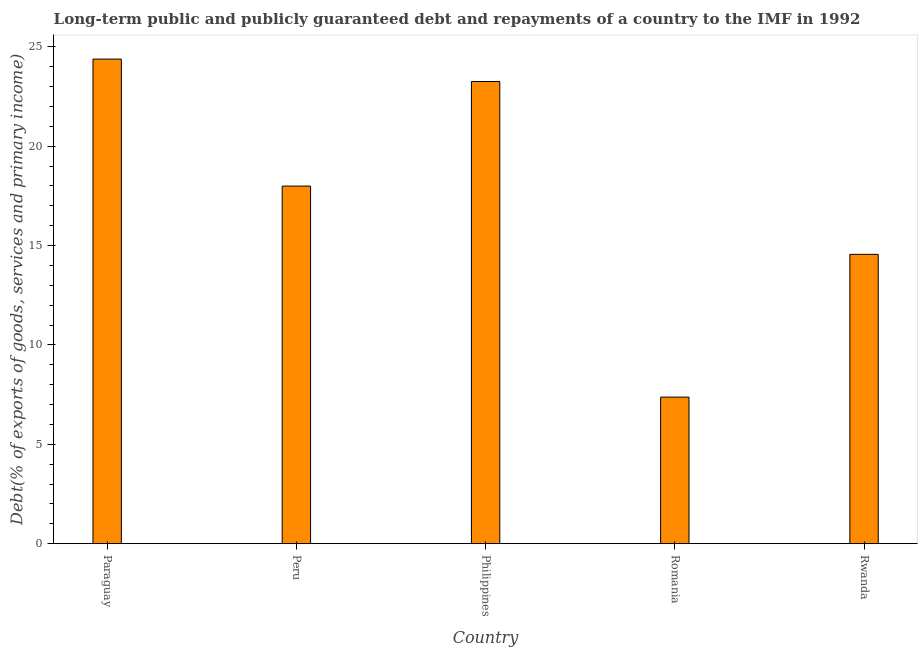Does the graph contain grids?
Provide a short and direct response. No. What is the title of the graph?
Ensure brevity in your answer.  Long-term public and publicly guaranteed debt and repayments of a country to the IMF in 1992. What is the label or title of the Y-axis?
Offer a very short reply. Debt(% of exports of goods, services and primary income). What is the debt service in Romania?
Offer a very short reply. 7.37. Across all countries, what is the maximum debt service?
Your answer should be compact. 24.38. Across all countries, what is the minimum debt service?
Keep it short and to the point. 7.37. In which country was the debt service maximum?
Provide a short and direct response. Paraguay. In which country was the debt service minimum?
Ensure brevity in your answer.  Romania. What is the sum of the debt service?
Offer a terse response. 87.55. What is the difference between the debt service in Peru and Romania?
Keep it short and to the point. 10.62. What is the average debt service per country?
Your response must be concise. 17.51. What is the median debt service?
Offer a terse response. 17.99. What is the ratio of the debt service in Peru to that in Rwanda?
Your response must be concise. 1.24. What is the difference between the highest and the second highest debt service?
Ensure brevity in your answer.  1.13. Is the sum of the debt service in Paraguay and Rwanda greater than the maximum debt service across all countries?
Your answer should be compact. Yes. What is the difference between the highest and the lowest debt service?
Make the answer very short. 17.01. In how many countries, is the debt service greater than the average debt service taken over all countries?
Keep it short and to the point. 3. How many bars are there?
Give a very brief answer. 5. How many countries are there in the graph?
Your response must be concise. 5. What is the difference between two consecutive major ticks on the Y-axis?
Your response must be concise. 5. Are the values on the major ticks of Y-axis written in scientific E-notation?
Keep it short and to the point. No. What is the Debt(% of exports of goods, services and primary income) of Paraguay?
Offer a terse response. 24.38. What is the Debt(% of exports of goods, services and primary income) of Peru?
Make the answer very short. 17.99. What is the Debt(% of exports of goods, services and primary income) of Philippines?
Offer a very short reply. 23.25. What is the Debt(% of exports of goods, services and primary income) of Romania?
Your response must be concise. 7.37. What is the Debt(% of exports of goods, services and primary income) in Rwanda?
Keep it short and to the point. 14.56. What is the difference between the Debt(% of exports of goods, services and primary income) in Paraguay and Peru?
Ensure brevity in your answer.  6.39. What is the difference between the Debt(% of exports of goods, services and primary income) in Paraguay and Philippines?
Keep it short and to the point. 1.13. What is the difference between the Debt(% of exports of goods, services and primary income) in Paraguay and Romania?
Offer a terse response. 17.01. What is the difference between the Debt(% of exports of goods, services and primary income) in Paraguay and Rwanda?
Your answer should be very brief. 9.82. What is the difference between the Debt(% of exports of goods, services and primary income) in Peru and Philippines?
Your answer should be compact. -5.26. What is the difference between the Debt(% of exports of goods, services and primary income) in Peru and Romania?
Offer a very short reply. 10.62. What is the difference between the Debt(% of exports of goods, services and primary income) in Peru and Rwanda?
Your answer should be compact. 3.43. What is the difference between the Debt(% of exports of goods, services and primary income) in Philippines and Romania?
Provide a succinct answer. 15.88. What is the difference between the Debt(% of exports of goods, services and primary income) in Philippines and Rwanda?
Your answer should be very brief. 8.7. What is the difference between the Debt(% of exports of goods, services and primary income) in Romania and Rwanda?
Offer a terse response. -7.18. What is the ratio of the Debt(% of exports of goods, services and primary income) in Paraguay to that in Peru?
Make the answer very short. 1.35. What is the ratio of the Debt(% of exports of goods, services and primary income) in Paraguay to that in Philippines?
Keep it short and to the point. 1.05. What is the ratio of the Debt(% of exports of goods, services and primary income) in Paraguay to that in Romania?
Provide a succinct answer. 3.31. What is the ratio of the Debt(% of exports of goods, services and primary income) in Paraguay to that in Rwanda?
Your answer should be very brief. 1.68. What is the ratio of the Debt(% of exports of goods, services and primary income) in Peru to that in Philippines?
Your answer should be compact. 0.77. What is the ratio of the Debt(% of exports of goods, services and primary income) in Peru to that in Romania?
Provide a succinct answer. 2.44. What is the ratio of the Debt(% of exports of goods, services and primary income) in Peru to that in Rwanda?
Offer a very short reply. 1.24. What is the ratio of the Debt(% of exports of goods, services and primary income) in Philippines to that in Romania?
Give a very brief answer. 3.15. What is the ratio of the Debt(% of exports of goods, services and primary income) in Philippines to that in Rwanda?
Your answer should be very brief. 1.6. What is the ratio of the Debt(% of exports of goods, services and primary income) in Romania to that in Rwanda?
Ensure brevity in your answer.  0.51. 